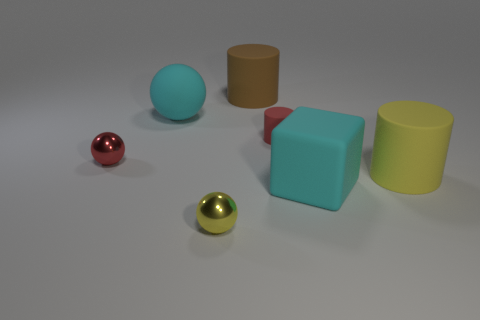What time of day does the lighting in the photo suggest? The lighting does not suggest a specific time of day as it seems to be artificially created, likely in a controlled indoor environment. 